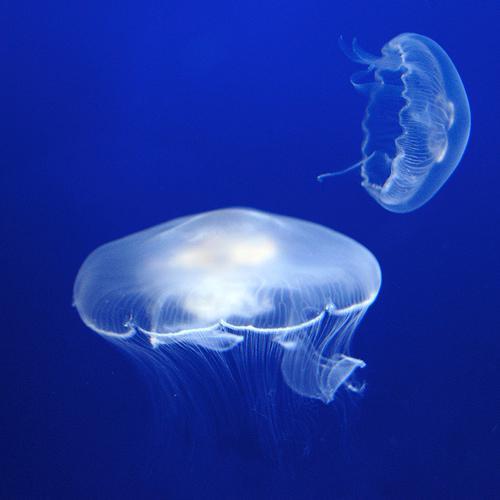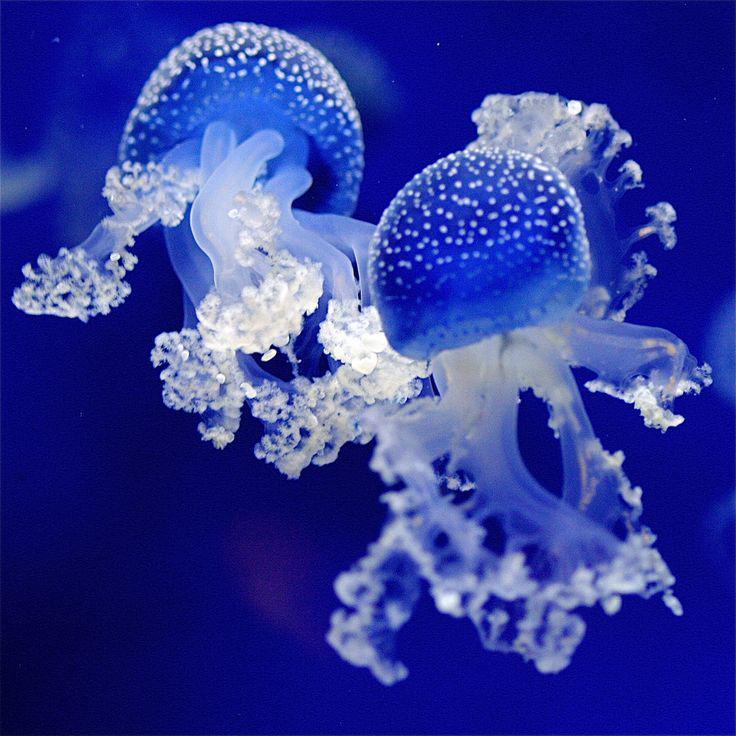The first image is the image on the left, the second image is the image on the right. Considering the images on both sides, is "Some jellyfish are traveling downwards." valid? Answer yes or no. No. 